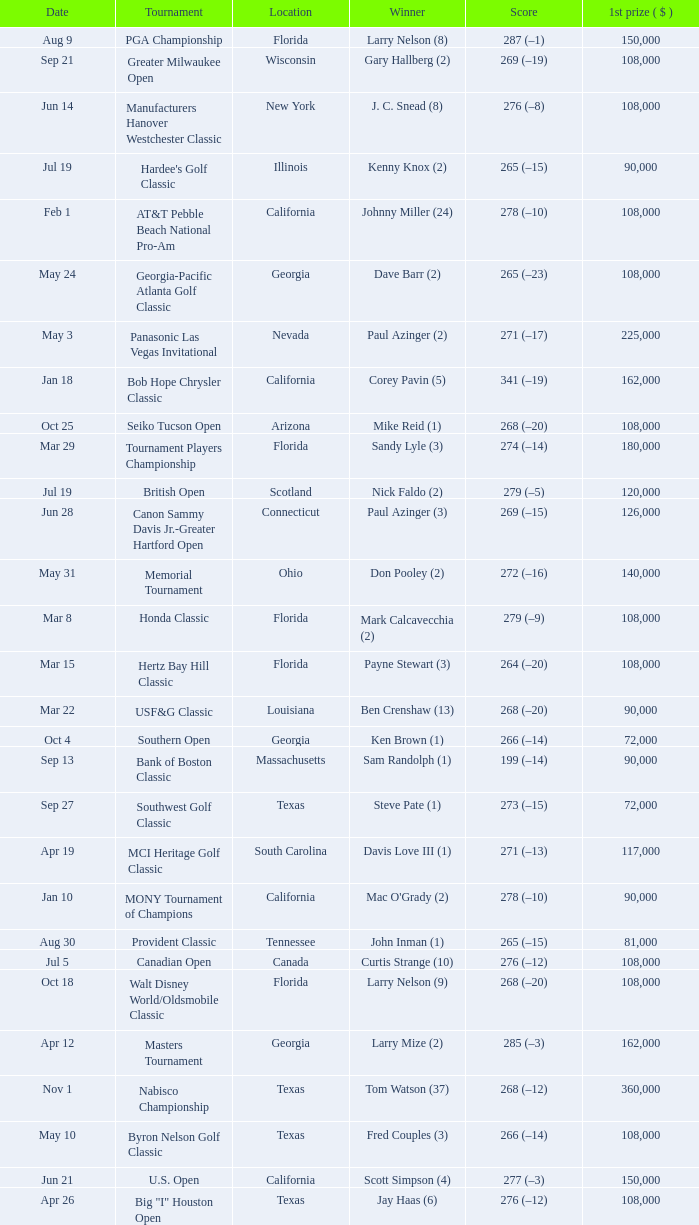What is the score from the winner Keith Clearwater (1)? 266 (–14). 